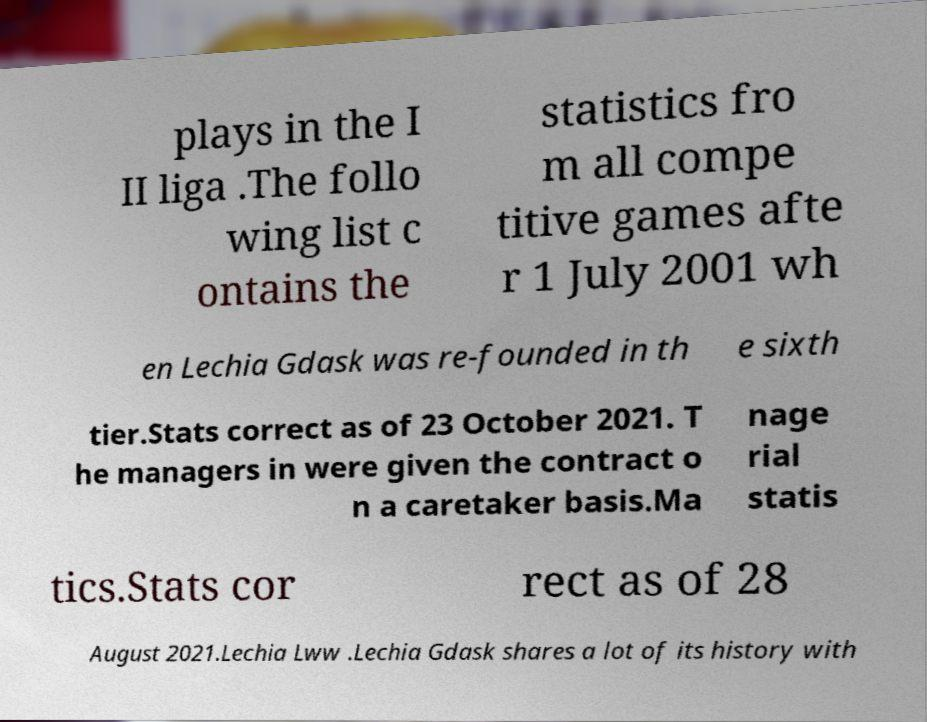Can you read and provide the text displayed in the image?This photo seems to have some interesting text. Can you extract and type it out for me? plays in the I II liga .The follo wing list c ontains the statistics fro m all compe titive games afte r 1 July 2001 wh en Lechia Gdask was re-founded in th e sixth tier.Stats correct as of 23 October 2021. T he managers in were given the contract o n a caretaker basis.Ma nage rial statis tics.Stats cor rect as of 28 August 2021.Lechia Lww .Lechia Gdask shares a lot of its history with 